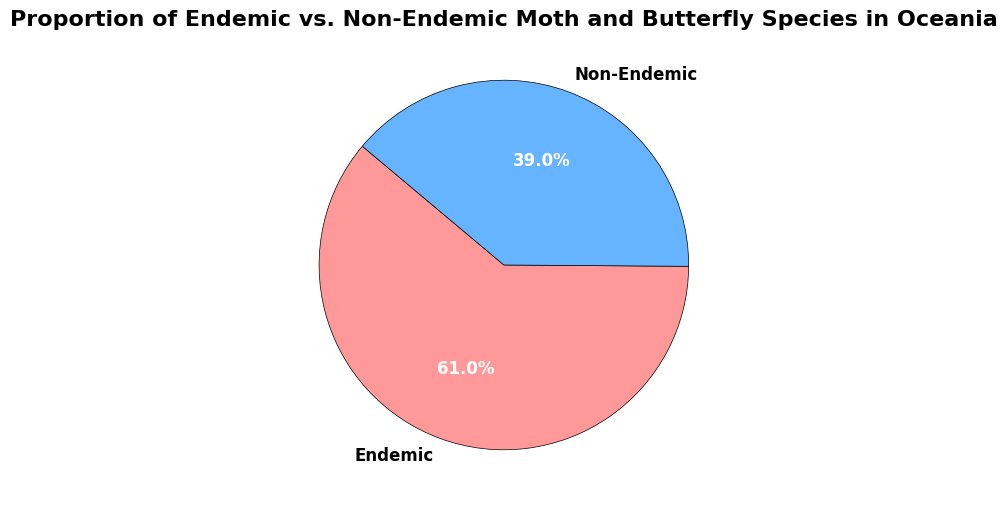What percentage of moth and butterfly species in Oceania are endemic? The pie chart shows the percentage next to the segment labeled "Endemic."
Answer: 61.0% What percentage of moth and butterfly species in Oceania are non-endemic? The pie chart shows the percentage next to the segment labeled "Non-Endemic."
Answer: 39.0% Which group has a higher proportion of species, endemic or non-endemic? The segment labeled "Endemic" is larger than the segment labeled "Non-Endemic," indicating a higher proportion of species.
Answer: Endemic What is the difference in the number of species between endemic and non-endemic groups? The pie chart indicates the counts of species: Endemic has 1,234 and Non-Endemic has 789. The difference is calculated as 1,234 - 789.
Answer: 445 What is the ratio of endemic to non-endemic species in Oceania? The ratio of species is calculated by dividing the count of endemic species by the count of non-endemic species: 1,234 / 789.
Answer: 1.56 If the total number of species is considered, what is the combined percentage of endemic and non-endemic species that make up the pie chart? The pie chart segments display percentages that add up to represent the whole. The total combined percentage for a complete pie chart is 100%.
Answer: 100% Which color represents the endemic species in the pie chart? The segment representing the endemic species is colored red.
Answer: Red By how many species do endemic species outnumber non-endemic species? The counts from the pie chart are: Endemic (1,234) and Non-Endemic (789). The number by which endemic species outnumber non-endemic species is the difference 1,234 - 789.
Answer: 445 What is the total number of species represented in the pie chart? The combined total is calculated from adding the counts of endemic and non-endemic species: 1,234 + 789.
Answer: 2,023 If another region had the same total number of species but a 50/50 split between endemic and non-endemic, how many species of each would they have? For a 50/50 split of 2,023 species, each category would have half of the total: 2,023 / 2.
Answer: 1,011.5 